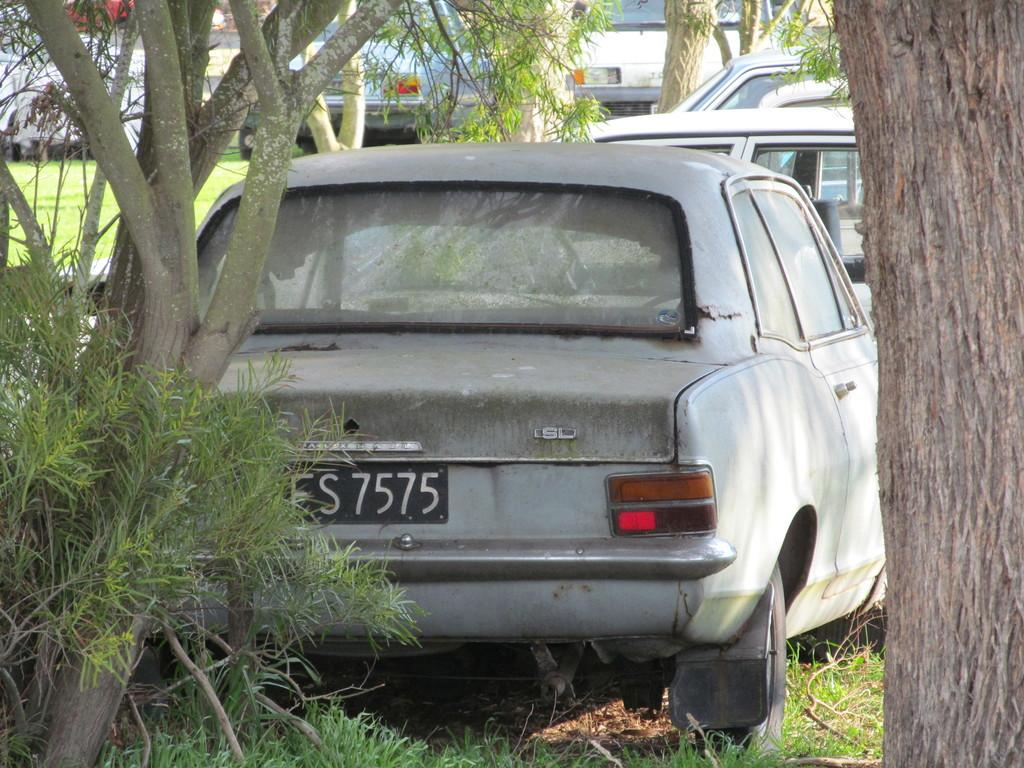What types of objects can be seen in the image? There are vehicles in the image. What natural elements are present in the image? There are trees and grass on the ground in the image. What type of horn can be seen on the trees in the image? There are no horns present on the trees in the image. Are there any bears visible in the image? There are no bears present in the image. 